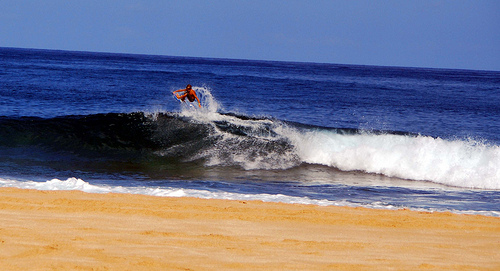Describe the feelings that this scene of surfing might evoke. The image radiates an exhilarating sense of freedom, with the surfer riding the wave representing a harmonious dance with nature, epitomizing both focus and serenity against the vast, open seascape. 